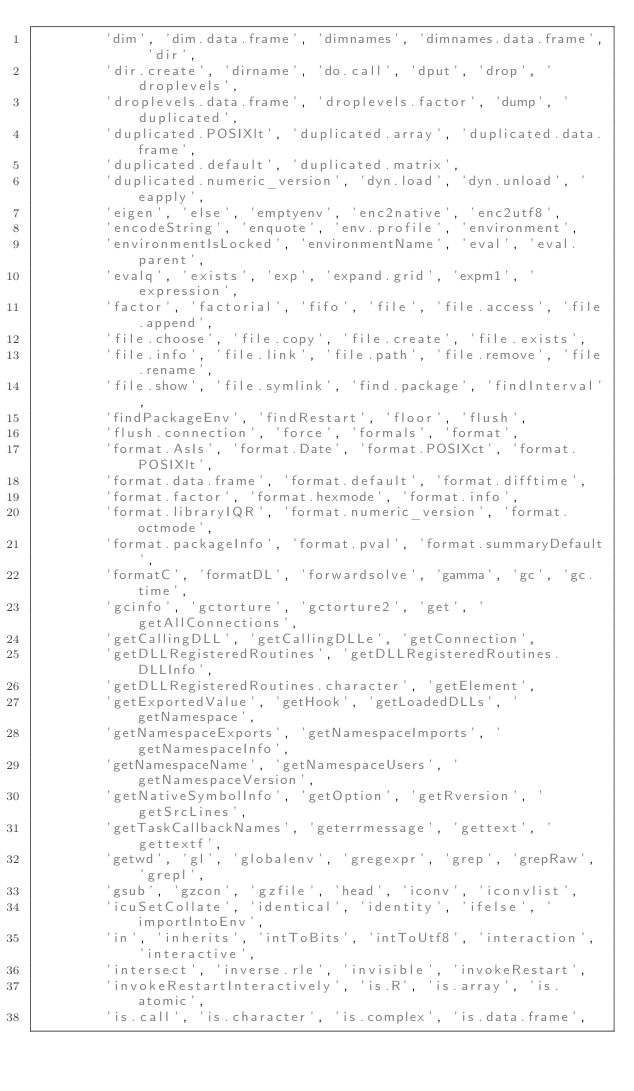Convert code to text. <code><loc_0><loc_0><loc_500><loc_500><_Cython_>        'dim', 'dim.data.frame', 'dimnames', 'dimnames.data.frame', 'dir',
        'dir.create', 'dirname', 'do.call', 'dput', 'drop', 'droplevels',
        'droplevels.data.frame', 'droplevels.factor', 'dump', 'duplicated',
        'duplicated.POSIXlt', 'duplicated.array', 'duplicated.data.frame',
        'duplicated.default', 'duplicated.matrix',
        'duplicated.numeric_version', 'dyn.load', 'dyn.unload', 'eapply',
        'eigen', 'else', 'emptyenv', 'enc2native', 'enc2utf8',
        'encodeString', 'enquote', 'env.profile', 'environment',
        'environmentIsLocked', 'environmentName', 'eval', 'eval.parent',
        'evalq', 'exists', 'exp', 'expand.grid', 'expm1', 'expression',
        'factor', 'factorial', 'fifo', 'file', 'file.access', 'file.append',
        'file.choose', 'file.copy', 'file.create', 'file.exists',
        'file.info', 'file.link', 'file.path', 'file.remove', 'file.rename',
        'file.show', 'file.symlink', 'find.package', 'findInterval',
        'findPackageEnv', 'findRestart', 'floor', 'flush',
        'flush.connection', 'force', 'formals', 'format',
        'format.AsIs', 'format.Date', 'format.POSIXct', 'format.POSIXlt',
        'format.data.frame', 'format.default', 'format.difftime',
        'format.factor', 'format.hexmode', 'format.info',
        'format.libraryIQR', 'format.numeric_version', 'format.octmode',
        'format.packageInfo', 'format.pval', 'format.summaryDefault',
        'formatC', 'formatDL', 'forwardsolve', 'gamma', 'gc', 'gc.time',
        'gcinfo', 'gctorture', 'gctorture2', 'get', 'getAllConnections',
        'getCallingDLL', 'getCallingDLLe', 'getConnection',
        'getDLLRegisteredRoutines', 'getDLLRegisteredRoutines.DLLInfo',
        'getDLLRegisteredRoutines.character', 'getElement',
        'getExportedValue', 'getHook', 'getLoadedDLLs', 'getNamespace',
        'getNamespaceExports', 'getNamespaceImports', 'getNamespaceInfo',
        'getNamespaceName', 'getNamespaceUsers', 'getNamespaceVersion',
        'getNativeSymbolInfo', 'getOption', 'getRversion', 'getSrcLines',
        'getTaskCallbackNames', 'geterrmessage', 'gettext', 'gettextf',
        'getwd', 'gl', 'globalenv', 'gregexpr', 'grep', 'grepRaw', 'grepl',
        'gsub', 'gzcon', 'gzfile', 'head', 'iconv', 'iconvlist',
        'icuSetCollate', 'identical', 'identity', 'ifelse', 'importIntoEnv',
        'in', 'inherits', 'intToBits', 'intToUtf8', 'interaction', 'interactive',
        'intersect', 'inverse.rle', 'invisible', 'invokeRestart',
        'invokeRestartInteractively', 'is.R', 'is.array', 'is.atomic',
        'is.call', 'is.character', 'is.complex', 'is.data.frame',</code> 